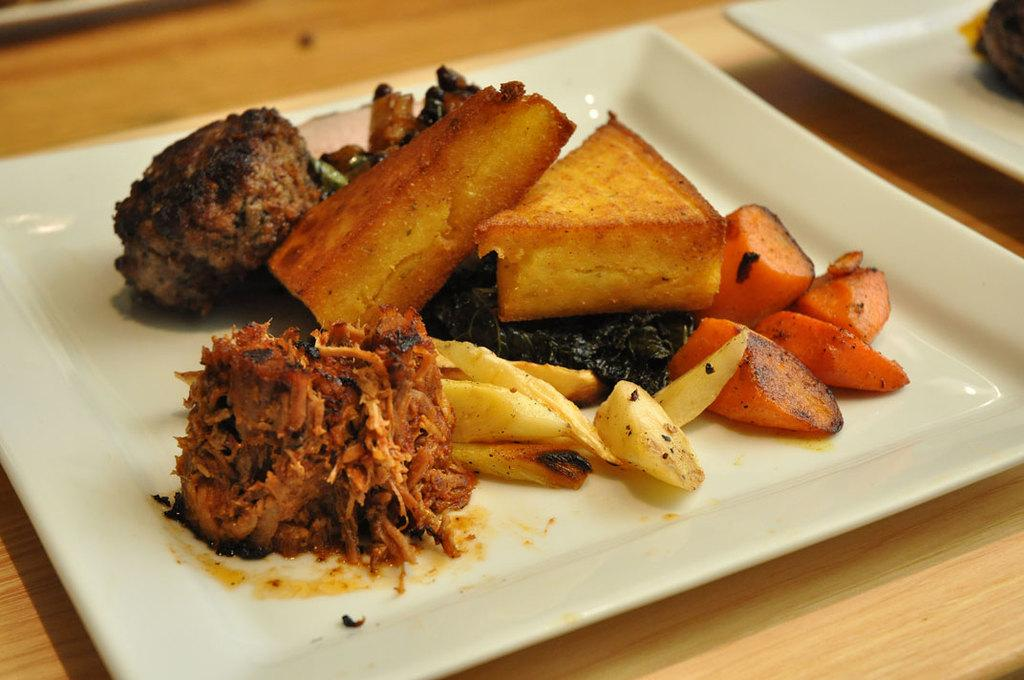What type of furniture is present in the image? There is a table in the image. What is placed on the table? There are white plates on the table. What is inside the plates? There are dishes in the plates. How does the squirrel show respect to the dishes in the image? There is no squirrel present in the image, so it cannot show respect to the dishes. 